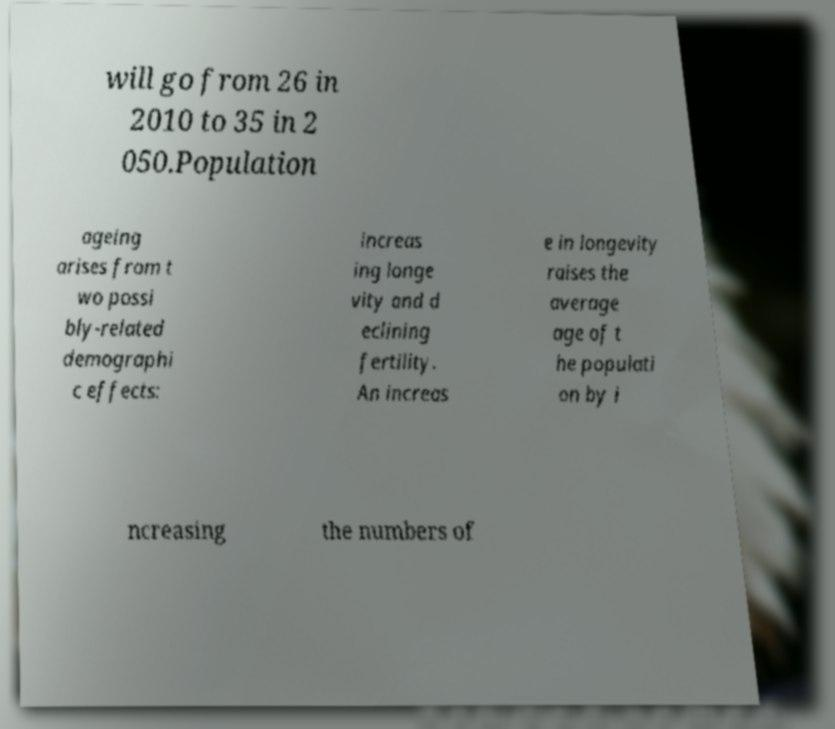Please identify and transcribe the text found in this image. will go from 26 in 2010 to 35 in 2 050.Population ageing arises from t wo possi bly-related demographi c effects: increas ing longe vity and d eclining fertility. An increas e in longevity raises the average age of t he populati on by i ncreasing the numbers of 